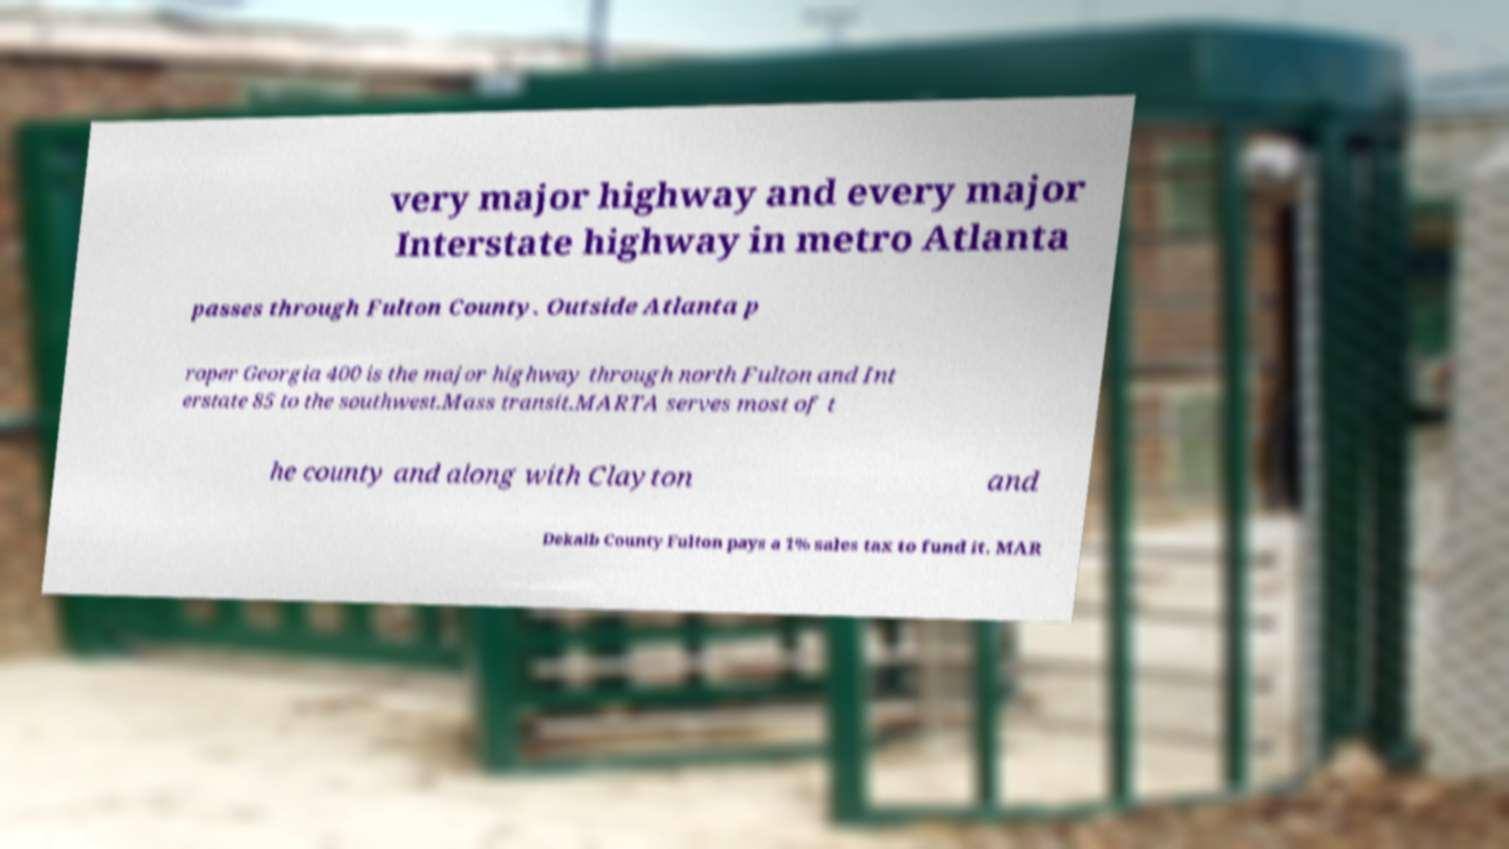Can you read and provide the text displayed in the image?This photo seems to have some interesting text. Can you extract and type it out for me? very major highway and every major Interstate highway in metro Atlanta passes through Fulton County. Outside Atlanta p roper Georgia 400 is the major highway through north Fulton and Int erstate 85 to the southwest.Mass transit.MARTA serves most of t he county and along with Clayton and Dekalb County Fulton pays a 1% sales tax to fund it. MAR 